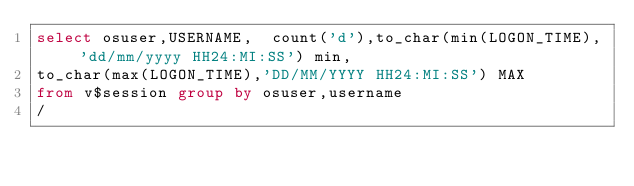<code> <loc_0><loc_0><loc_500><loc_500><_SQL_>select osuser,USERNAME,  count('d'),to_char(min(LOGON_TIME), 'dd/mm/yyyy HH24:MI:SS') min,
to_char(max(LOGON_TIME),'DD/MM/YYYY HH24:MI:SS') MAX
from v$session group by osuser,username
/
</code> 